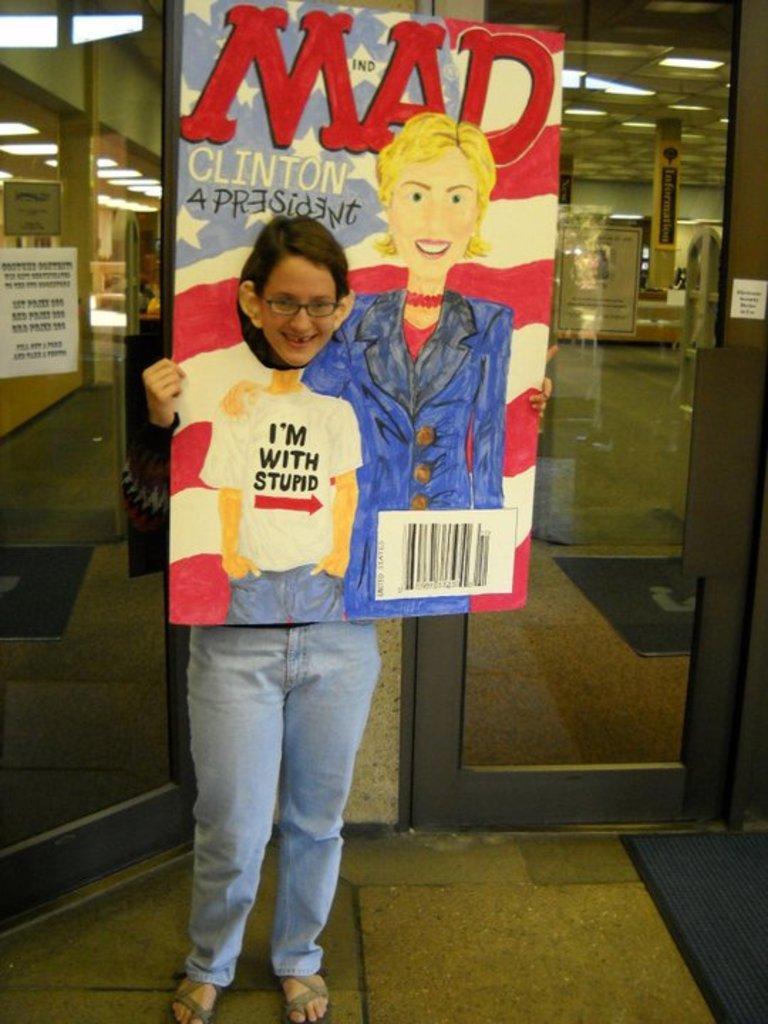Can you describe this image briefly? This image consists of a person holding a board. On which we can see a paining and text. In the background, there is a door. At the bottom, there is a floor. 